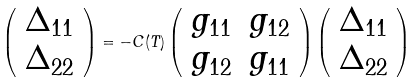Convert formula to latex. <formula><loc_0><loc_0><loc_500><loc_500>\left ( \begin{array} { c } \Delta _ { 1 1 } \\ \Delta _ { 2 2 } \end{array} \right ) = - C ( T ) \left ( \begin{array} { c c } g _ { 1 1 } & g _ { 1 2 } \\ g _ { 1 2 } & g _ { 1 1 } \end{array} \right ) \left ( \begin{array} { r } \Delta _ { 1 1 } \\ \Delta _ { 2 2 } \end{array} \right )</formula> 